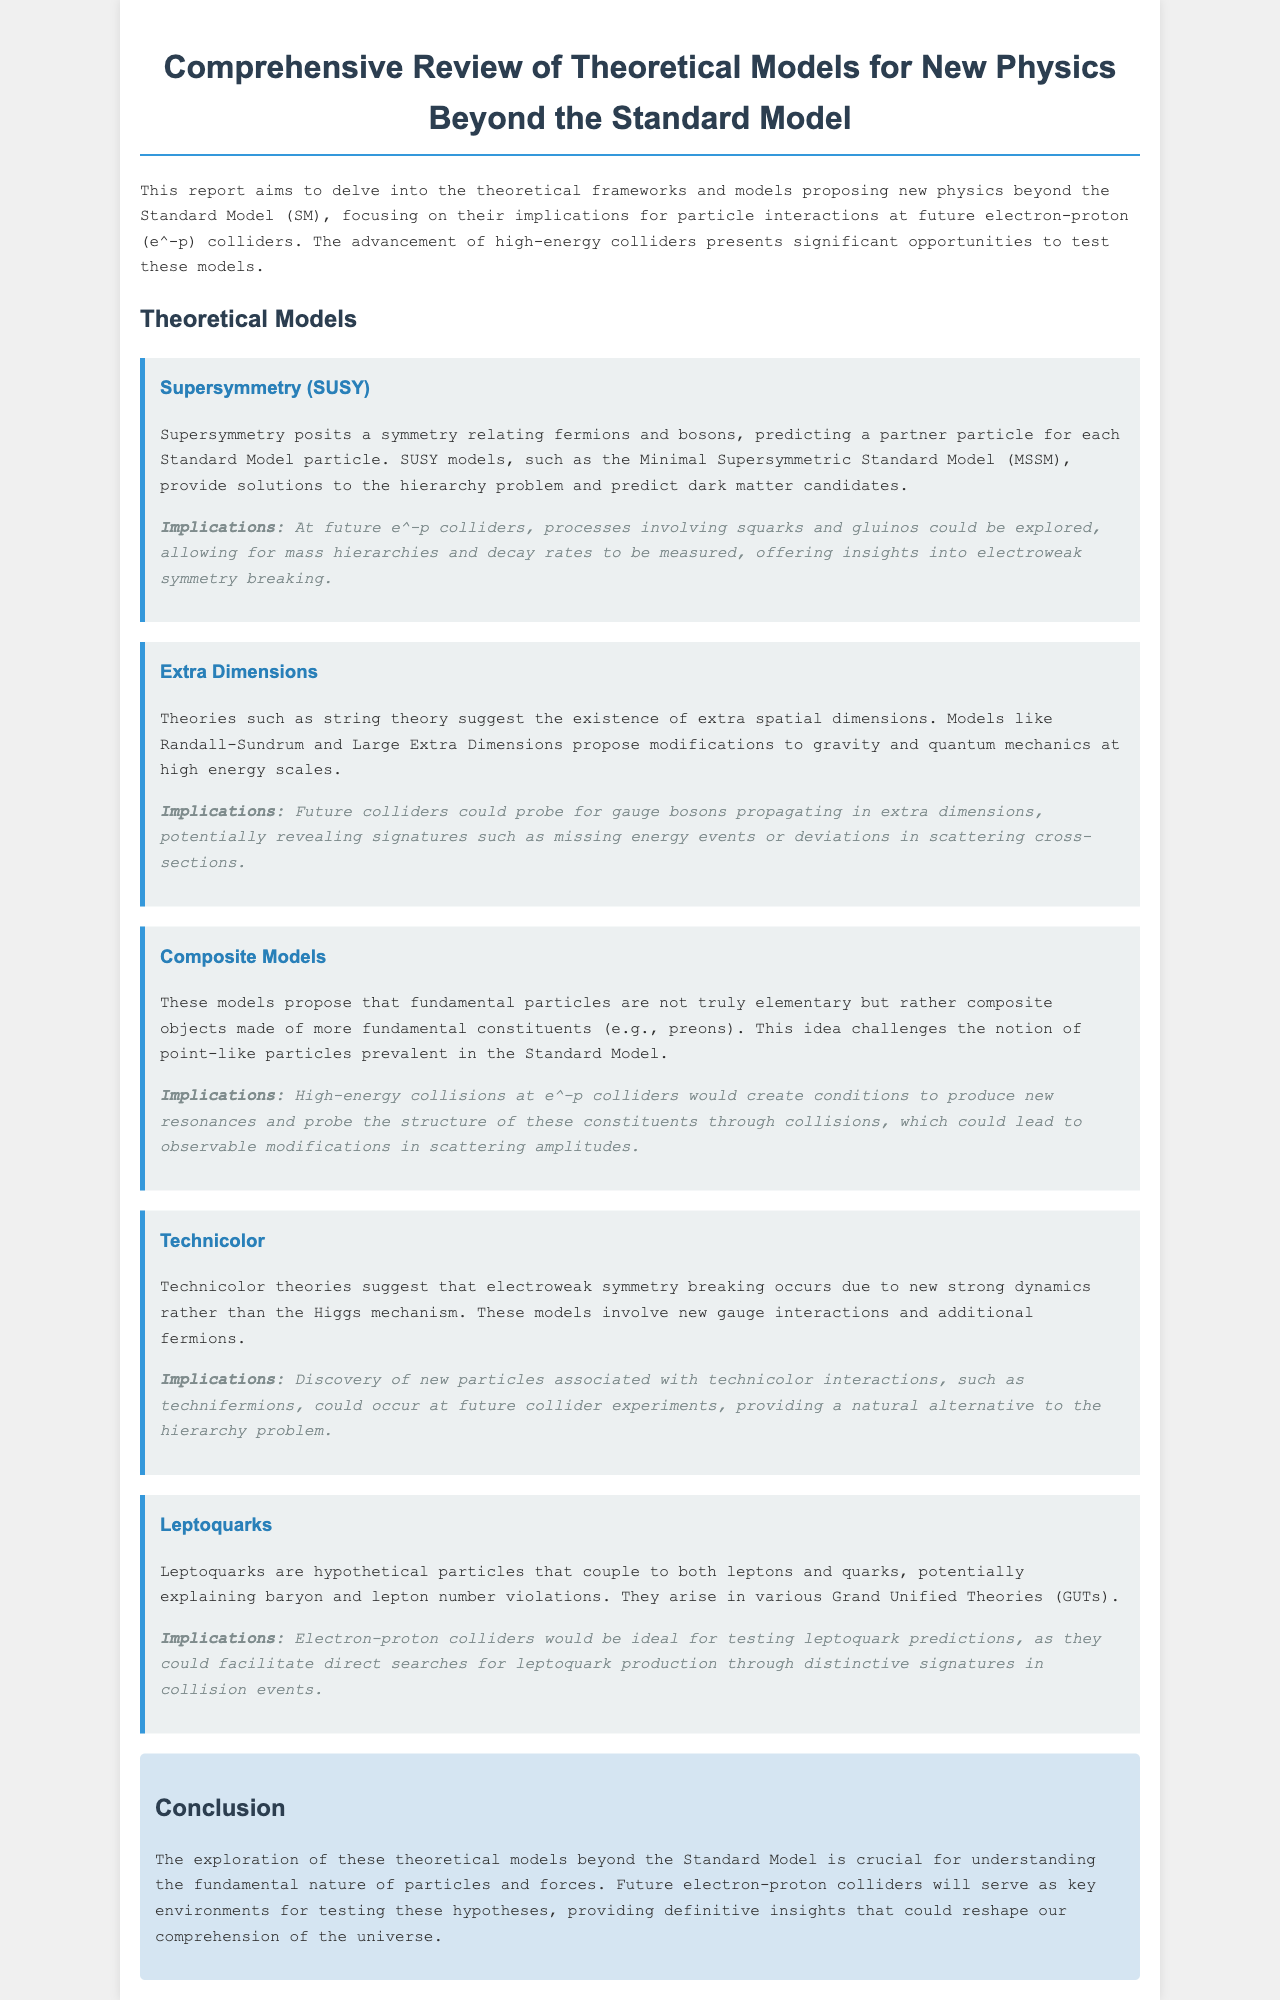What is the title of the report? The title of the report is clearly indicated at the beginning of the document, highlighting its comprehensive review nature.
Answer: Comprehensive Review of Theoretical Models for New Physics Beyond the Standard Model What theoretical framework involves particles that couple to both leptons and quarks? The document outlines various theoretical frameworks, specifically identifying the one in question in the section regarding leptoquarks.
Answer: Leptoquarks Which model provides solutions to the hierarchy problem? This model is discussed in the context of supersymmetry, which aims to address the hierarchy issue in particle physics.
Answer: Supersymmetry How many theoretical models are discussed in the document? The document lists several models in the section on theoretical models, explicitly naming and explaining each one.
Answer: Five What is one predicted signature from extra dimensions theories? The implications section describes potential signatures that future colliders could reveal from this theoretical framework, mentioning specific observable effects.
Answer: Missing energy events What does technicolor focus on regarding electroweak symmetry breaking? The document explains the technicolor model's stance on the mechanism behind electroweak symmetry breaking, emphasizing an alternative viewpoint.
Answer: New strong dynamics What aspect of future colliders is emphasized throughout the document? The document consistently highlights the opportunities presented by future electron-proton colliders for testing various theoretical models.
Answer: Testing theoretical models In what year was data considered for this report? The report does not specify a year for the data itself; however, the preamble notes the coverage limited to a specific time frame for context.
Answer: October 2023 